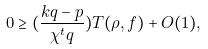Convert formula to latex. <formula><loc_0><loc_0><loc_500><loc_500>0 \geq ( \frac { k q - p } { \chi ^ { t } q } ) T ( \rho , f ) + O ( 1 ) ,</formula> 